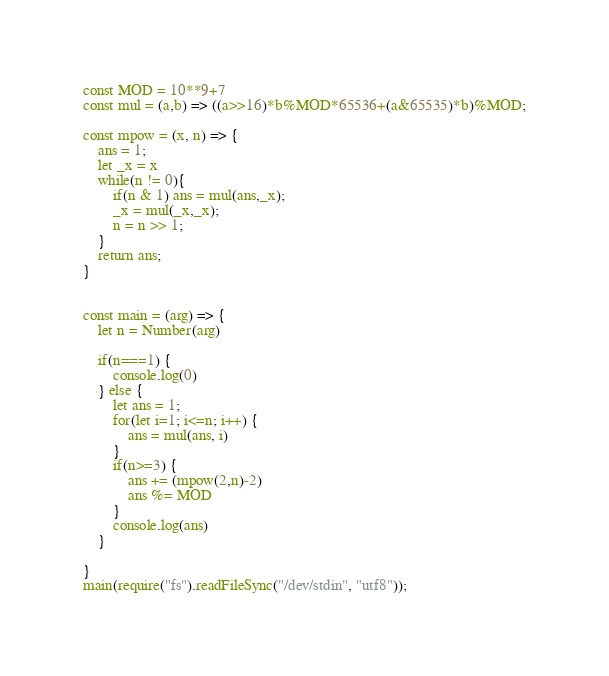Convert code to text. <code><loc_0><loc_0><loc_500><loc_500><_JavaScript_>const MOD = 10**9+7
const mul = (a,b) => ((a>>16)*b%MOD*65536+(a&65535)*b)%MOD;

const mpow = (x, n) => {
    ans = 1;
    let _x = x
    while(n != 0){
        if(n & 1) ans = mul(ans,_x);
        _x = mul(_x,_x);
        n = n >> 1;
    }
    return ans;
}


const main = (arg) => {
  	let n = Number(arg)
  	
  	if(n===1) {
  	    console.log(0)
  	} else {
  	    let ans = 1;
      	for(let i=1; i<=n; i++) {
      	    ans = mul(ans, i)
      	}
      	if(n>=3) {
          	ans += (mpow(2,n)-2)
          	ans %= MOD
      	}
      	console.log(ans)
  	}    

}
main(require("fs").readFileSync("/dev/stdin", "utf8"));</code> 